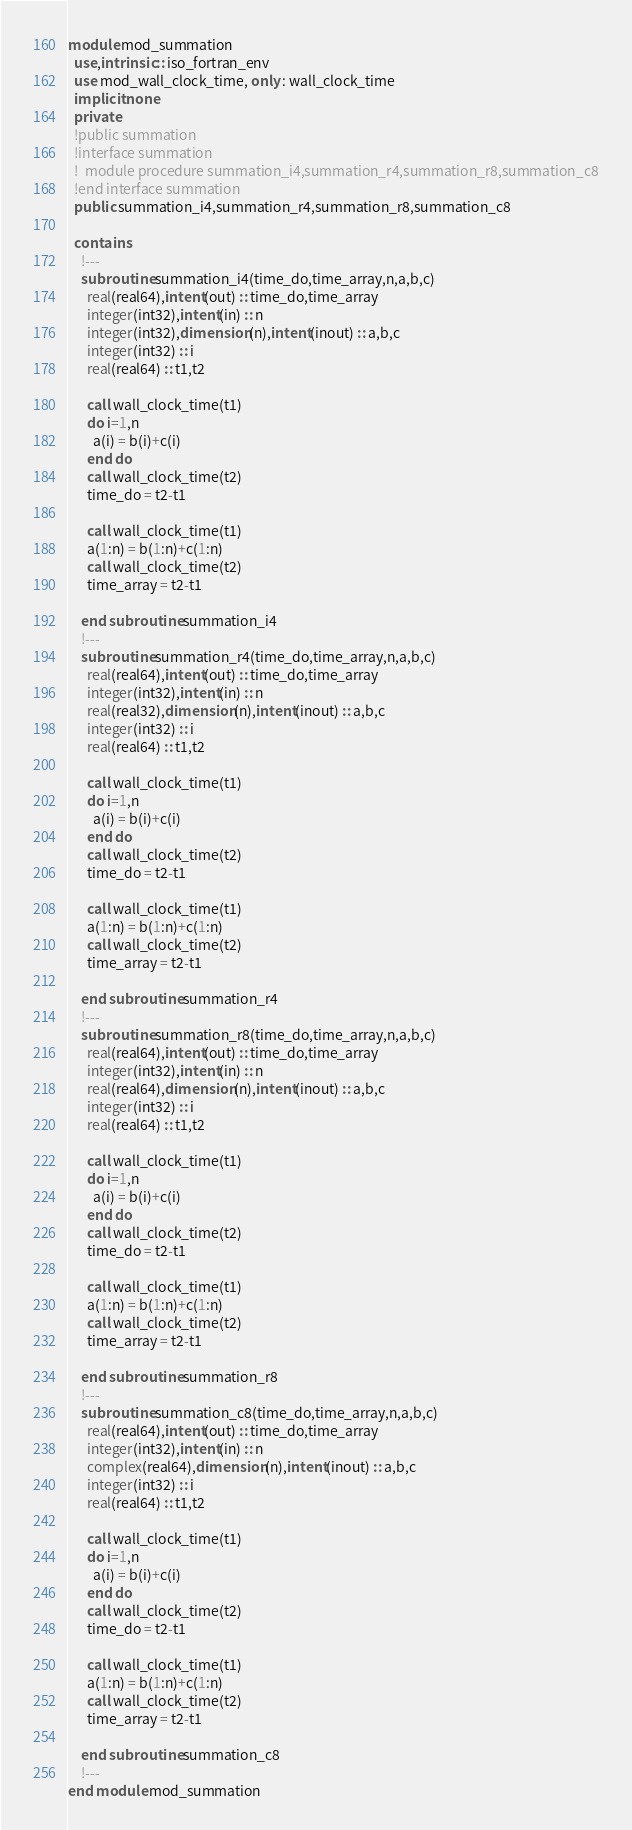<code> <loc_0><loc_0><loc_500><loc_500><_FORTRAN_>module mod_summation
  use,intrinsic :: iso_fortran_env
  use mod_wall_clock_time, only : wall_clock_time
  implicit none
  private
  !public summation
  !interface summation
  !  module procedure summation_i4,summation_r4,summation_r8,summation_c8
  !end interface summation
  public summation_i4,summation_r4,summation_r8,summation_c8

  contains
    !---
    subroutine summation_i4(time_do,time_array,n,a,b,c)
      real(real64),intent(out) :: time_do,time_array
      integer(int32),intent(in) :: n
      integer(int32),dimension(n),intent(inout) :: a,b,c
      integer(int32) :: i
      real(real64) :: t1,t2

      call wall_clock_time(t1)
      do i=1,n
        a(i) = b(i)+c(i)
      end do
      call wall_clock_time(t2)
      time_do = t2-t1

      call wall_clock_time(t1)
      a(1:n) = b(1:n)+c(1:n)
      call wall_clock_time(t2)
      time_array = t2-t1

    end subroutine summation_i4
    !---
    subroutine summation_r4(time_do,time_array,n,a,b,c)
      real(real64),intent(out) :: time_do,time_array
      integer(int32),intent(in) :: n
      real(real32),dimension(n),intent(inout) :: a,b,c
      integer(int32) :: i
      real(real64) :: t1,t2

      call wall_clock_time(t1)
      do i=1,n
        a(i) = b(i)+c(i)
      end do
      call wall_clock_time(t2)
      time_do = t2-t1

      call wall_clock_time(t1)
      a(1:n) = b(1:n)+c(1:n)
      call wall_clock_time(t2)
      time_array = t2-t1

    end subroutine summation_r4
    !---
    subroutine summation_r8(time_do,time_array,n,a,b,c)
      real(real64),intent(out) :: time_do,time_array
      integer(int32),intent(in) :: n
      real(real64),dimension(n),intent(inout) :: a,b,c
      integer(int32) :: i
      real(real64) :: t1,t2

      call wall_clock_time(t1)
      do i=1,n
        a(i) = b(i)+c(i)
      end do
      call wall_clock_time(t2)
      time_do = t2-t1

      call wall_clock_time(t1)
      a(1:n) = b(1:n)+c(1:n)
      call wall_clock_time(t2)
      time_array = t2-t1

    end subroutine summation_r8
    !---
    subroutine summation_c8(time_do,time_array,n,a,b,c)
      real(real64),intent(out) :: time_do,time_array
      integer(int32),intent(in) :: n
      complex(real64),dimension(n),intent(inout) :: a,b,c
      integer(int32) :: i
      real(real64) :: t1,t2

      call wall_clock_time(t1)
      do i=1,n
        a(i) = b(i)+c(i)
      end do
      call wall_clock_time(t2)
      time_do = t2-t1

      call wall_clock_time(t1)
      a(1:n) = b(1:n)+c(1:n)
      call wall_clock_time(t2)
      time_array = t2-t1

    end subroutine summation_c8
    !---
end module mod_summation</code> 